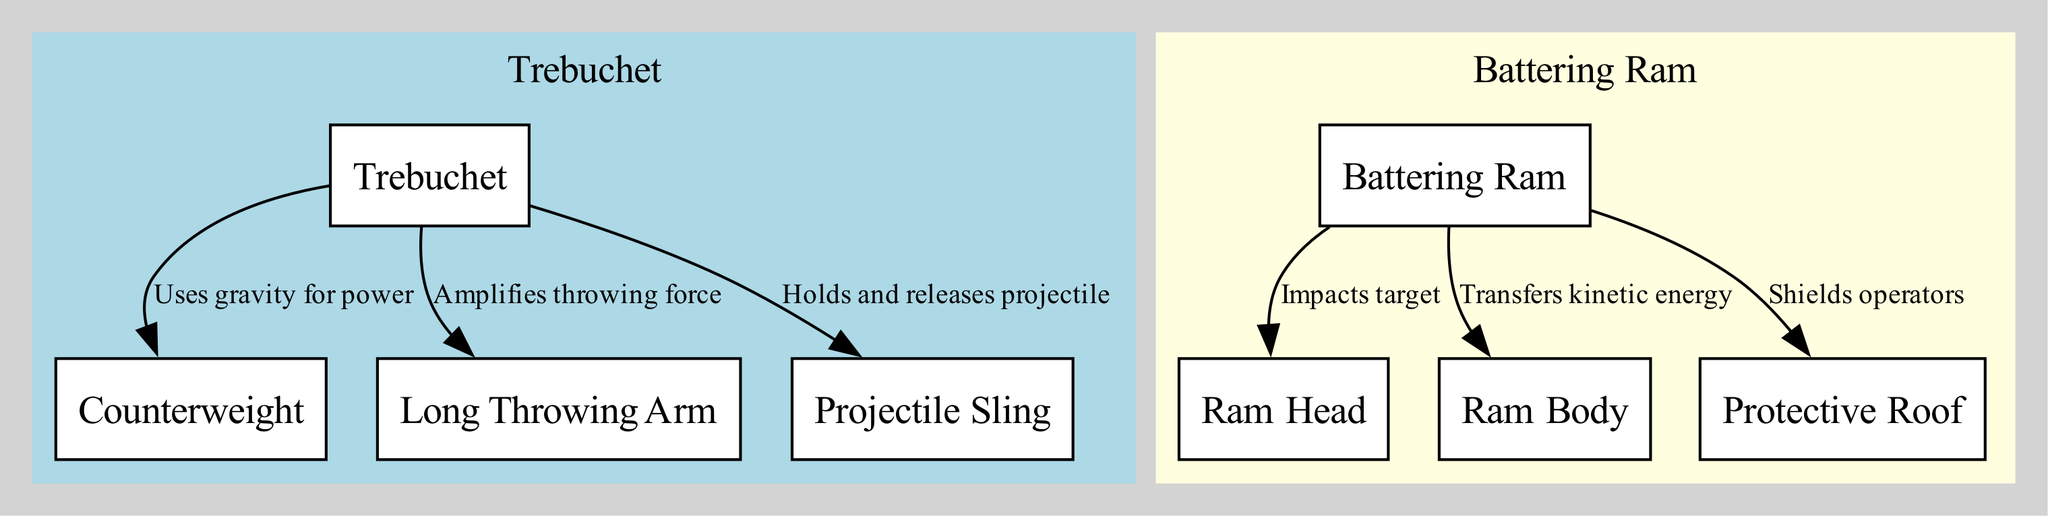What is the main power source for the trebuchet? The diagram illustrates that the trebuchet uses a counterweight for power, as indicated by the edge labeled "Uses gravity for power" connecting the trebuchet to the counterweight.
Answer: Counterweight How many nodes represent components of the battering ram? The diagram shows three nodes related to the battering ram: ram head, ram body, and protective roof. Counting these nodes gives a total of three components.
Answer: Three Which component of the trebuchet is responsible for holding and releasing the projectile? In the diagram, the edge labeled "Holds and releases projectile" connects the trebuchet to the projectile sling, indicating that the projectile sling plays this role.
Answer: Projectile Sling What does the ram body do in relation to the battering ram? The edge labeled "Transfers kinetic energy" shows that the ram body is responsible for this function, meaning it carries the energy generated during the battering ram's movement to the target.
Answer: Transfers kinetic energy Which component of the trebuchet amplifies the throwing force? The diagram highlights that the long throwing arm (beam) is the part that amplifies the throwing force of the trebuchet, as confirmed by the edge labeled "Amplifies throwing force."
Answer: Long Throwing Arm What protective feature is associated with the battering ram? The diagram indicates that a protective roof is present to shield operators of the battering ram, highlighted by the connection labeled "Shields operators."
Answer: Protective Roof Which siege weapon releases its projectile via a sling? The trebuchet is identified as releasing its projectile with a sling, as represented in the diagram with a connection saying, "Holds and releases projectile."
Answer: Trebuchet How is the target impacted by the battering ram? According to the edge labeled "Impacts target," the ram head performs the action of impacting the target.
Answer: Ram Head What is the relationship between the beam and the trebuchet? The diagram indicates that the beam amplifies the throwing force of the trebuchet through the edge labeled "Amplifies throwing force." This relationship is essential for the trebuchet's operation.
Answer: Amplifies throwing force 